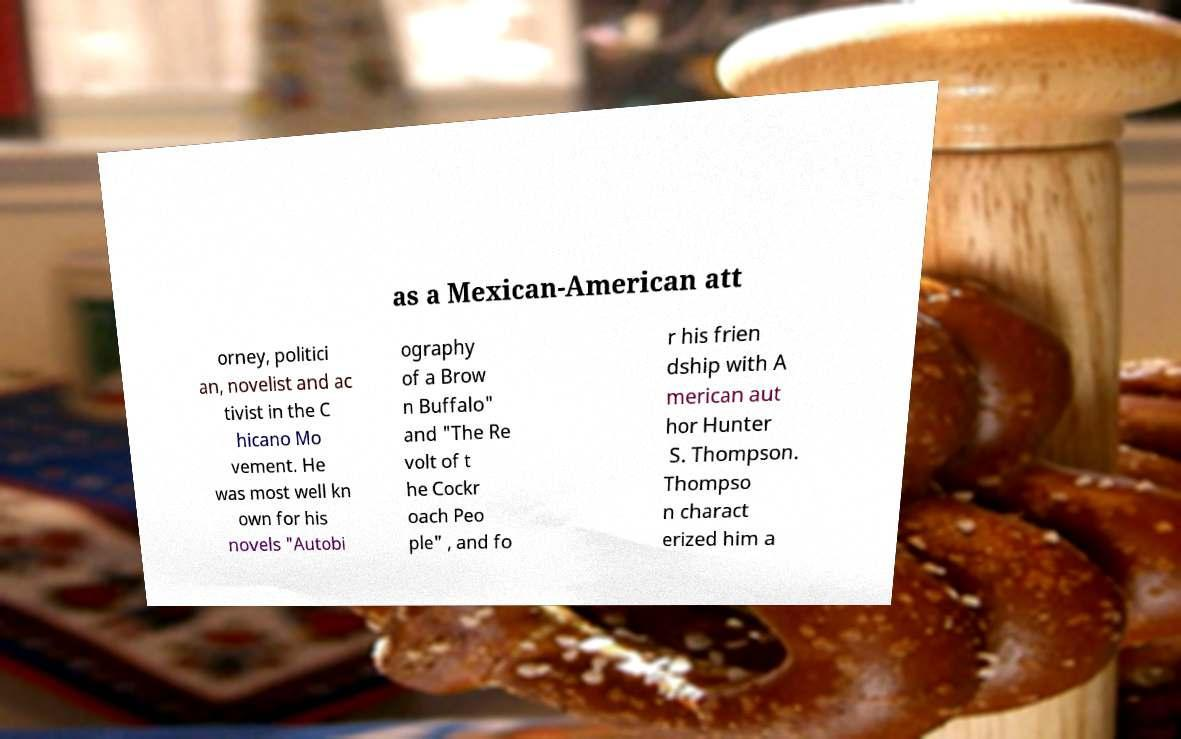Please read and relay the text visible in this image. What does it say? as a Mexican-American att orney, politici an, novelist and ac tivist in the C hicano Mo vement. He was most well kn own for his novels "Autobi ography of a Brow n Buffalo" and "The Re volt of t he Cockr oach Peo ple" , and fo r his frien dship with A merican aut hor Hunter S. Thompson. Thompso n charact erized him a 